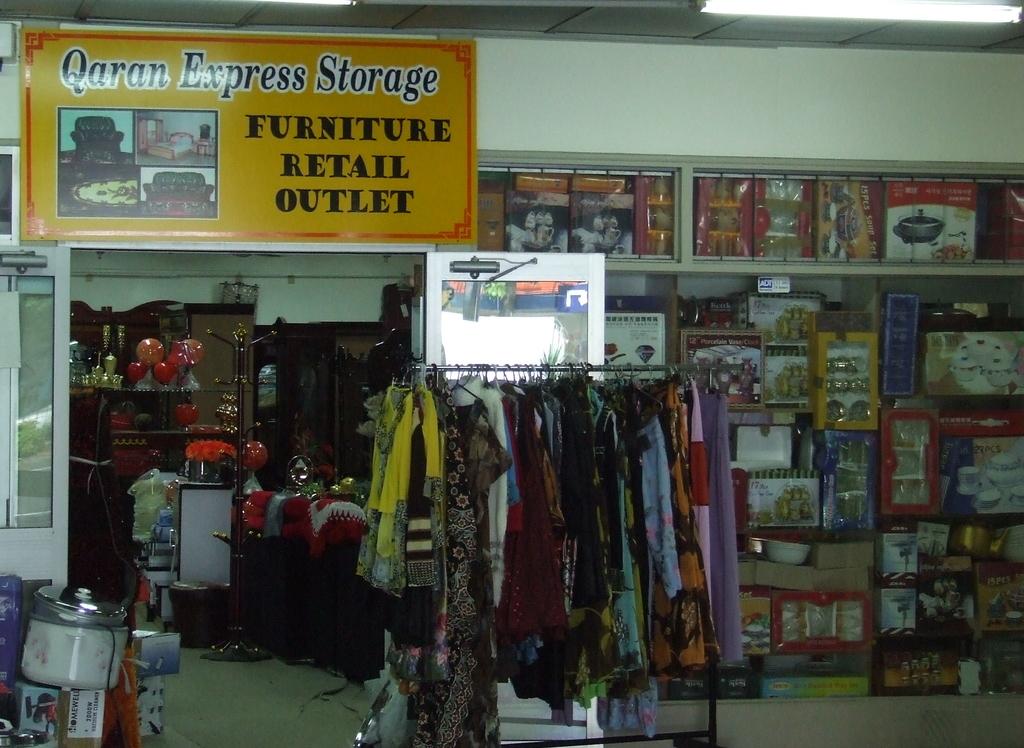What type of retail outlet is this?
Ensure brevity in your answer.  Furniture. Where does the outlet obtain its product from?
Provide a short and direct response. Qaran express storage. 